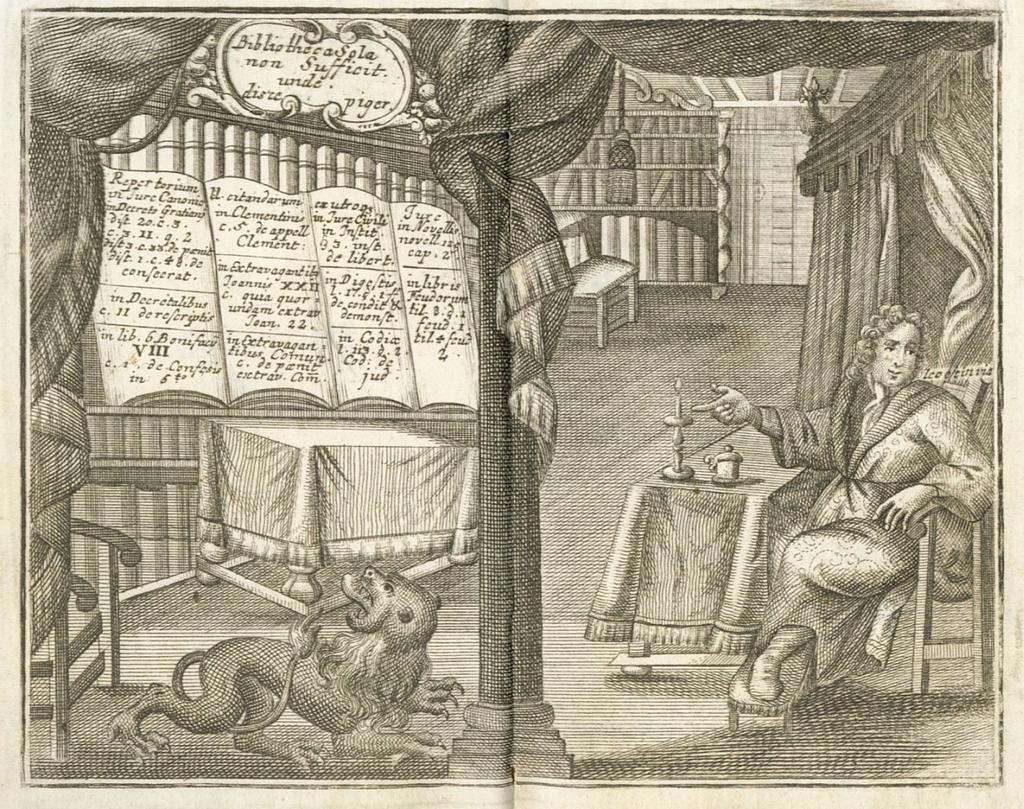Describe this image in one or two sentences. We can see poster, on this poster we can see person,animal and objects on the table. 